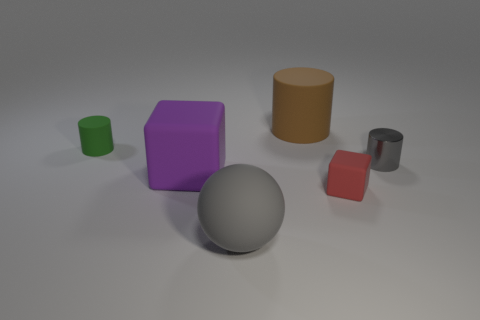Add 1 small gray rubber cylinders. How many objects exist? 7 Subtract all spheres. How many objects are left? 5 Add 6 small gray shiny cylinders. How many small gray shiny cylinders exist? 7 Subtract 0 yellow spheres. How many objects are left? 6 Subtract all large rubber things. Subtract all tiny matte cylinders. How many objects are left? 2 Add 3 tiny gray objects. How many tiny gray objects are left? 4 